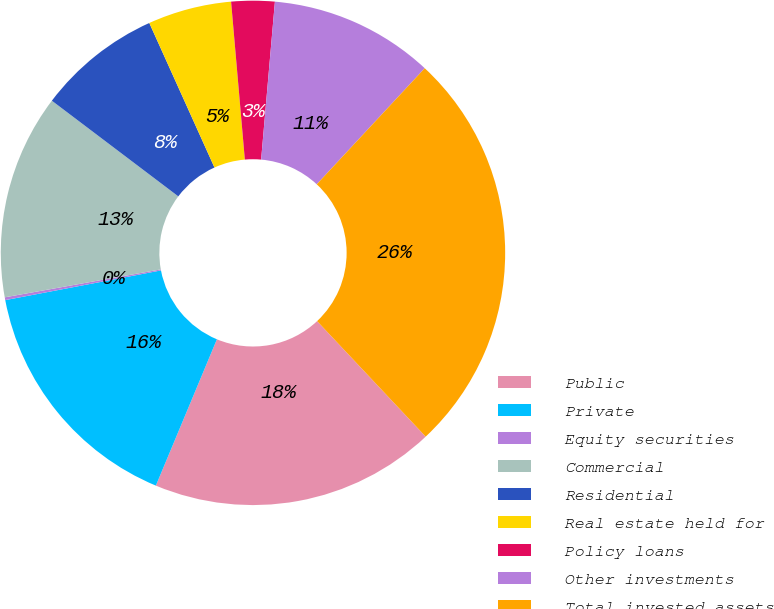Convert chart to OTSL. <chart><loc_0><loc_0><loc_500><loc_500><pie_chart><fcel>Public<fcel>Private<fcel>Equity securities<fcel>Commercial<fcel>Residential<fcel>Real estate held for<fcel>Policy loans<fcel>Other investments<fcel>Total invested assets<nl><fcel>18.3%<fcel>15.71%<fcel>0.18%<fcel>13.13%<fcel>7.95%<fcel>5.36%<fcel>2.77%<fcel>10.54%<fcel>26.07%<nl></chart> 